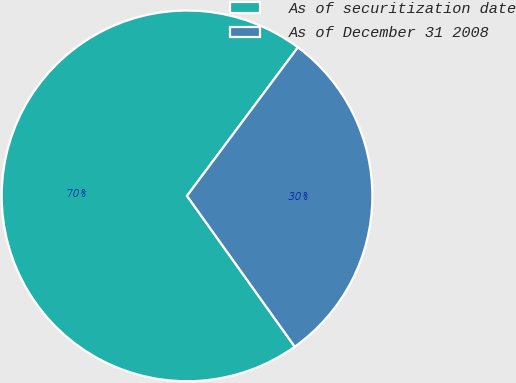Convert chart to OTSL. <chart><loc_0><loc_0><loc_500><loc_500><pie_chart><fcel>As of securitization date<fcel>As of December 31 2008<nl><fcel>70.08%<fcel>29.92%<nl></chart> 